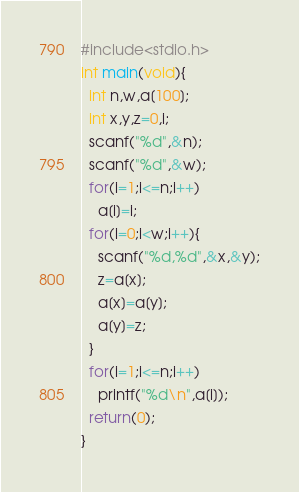<code> <loc_0><loc_0><loc_500><loc_500><_C_>#include<stdio.h>
int main(void){
  int n,w,a[100];
  int x,y,z=0,i;
  scanf("%d",&n);
  scanf("%d",&w);
  for(i=1;i<=n;i++)
    a[i]=i;
  for(i=0;i<w;i++){
    scanf("%d,%d",&x,&y);
    z=a[x];
    a[x]=a[y];
    a[y]=z;
  }
  for(i=1;i<=n;i++)
    printf("%d\n",a[i]);
  return(0);
}</code> 